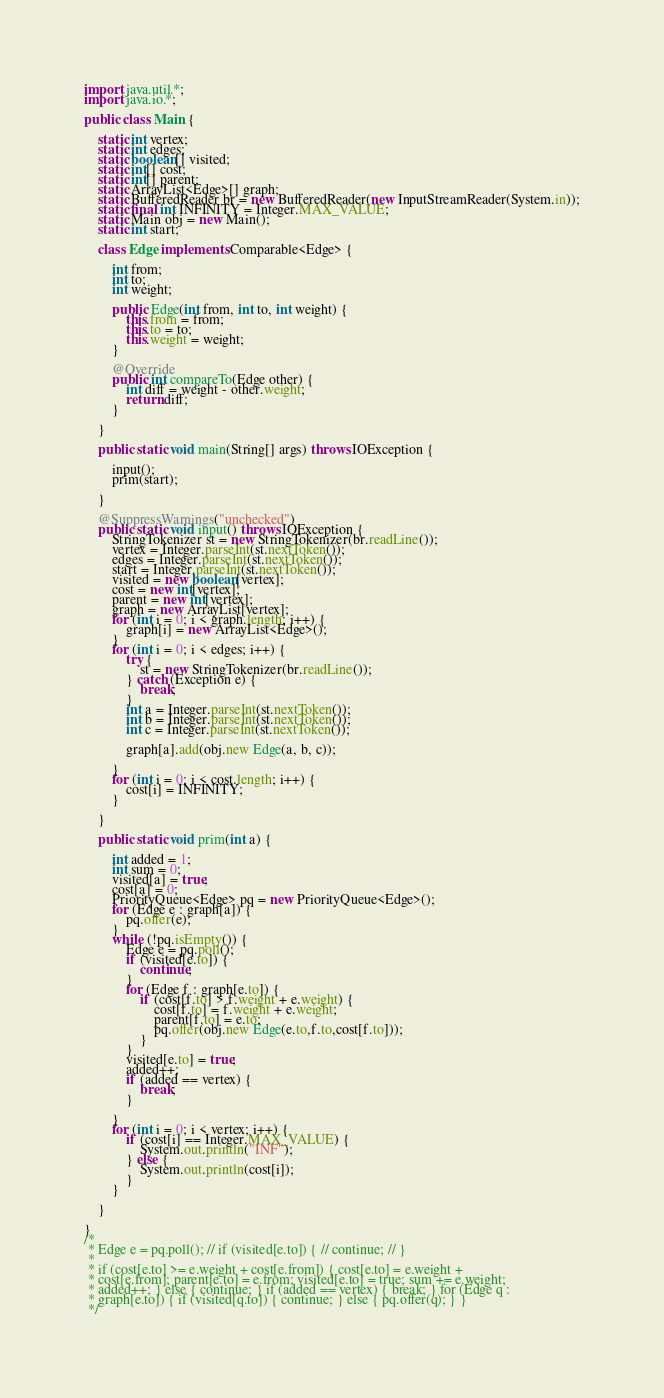Convert code to text. <code><loc_0><loc_0><loc_500><loc_500><_Java_>import java.util.*;
import java.io.*;

public class Main {

	static int vertex;
	static int edges;
	static boolean[] visited;
	static int[] cost;
	static int[] parent;
	static ArrayList<Edge>[] graph;
	static BufferedReader br = new BufferedReader(new InputStreamReader(System.in));
	static final int INFINITY = Integer.MAX_VALUE;
	static Main obj = new Main();
	static int start;

	class Edge implements Comparable<Edge> {

		int from;
		int to;
		int weight;

		public Edge(int from, int to, int weight) {
			this.from = from;
			this.to = to;
			this.weight = weight;
		}

		@Override
		public int compareTo(Edge other) {
			int diff = weight - other.weight;
			return diff;
		}

	}

	public static void main(String[] args) throws IOException {

		input();
		prim(start);

	}

	@SuppressWarnings("unchecked")
	public static void input() throws IOException {
		StringTokenizer st = new StringTokenizer(br.readLine());
		vertex = Integer.parseInt(st.nextToken());
		edges = Integer.parseInt(st.nextToken());
		start = Integer.parseInt(st.nextToken());
		visited = new boolean[vertex];
		cost = new int[vertex];
		parent = new int[vertex];
		graph = new ArrayList[vertex];
		for (int i = 0; i < graph.length; i++) {
			graph[i] = new ArrayList<Edge>();
		}
		for (int i = 0; i < edges; i++) {
			try {
				st = new StringTokenizer(br.readLine());
			} catch (Exception e) {
				break;
			}
			int a = Integer.parseInt(st.nextToken());
			int b = Integer.parseInt(st.nextToken());
			int c = Integer.parseInt(st.nextToken());

			graph[a].add(obj.new Edge(a, b, c));

		}
		for (int i = 0; i < cost.length; i++) {
			cost[i] = INFINITY;
		}

	}

	public static void prim(int a) {

		int added = 1;
		int sum = 0;
		visited[a] = true;
		cost[a] = 0;
		PriorityQueue<Edge> pq = new PriorityQueue<Edge>();
		for (Edge e : graph[a]) {
			pq.offer(e);
		}
		while (!pq.isEmpty()) {
			Edge e = pq.poll();
			if (visited[e.to]) {
				continue;
			}
			for (Edge f : graph[e.to]) {
				if (cost[f.to] > f.weight + e.weight) {
					cost[f.to] = f.weight + e.weight;
					parent[f.to] = e.to;
					pq.offer(obj.new Edge(e.to,f.to,cost[f.to]));
				}
			}
			visited[e.to] = true;
			added++;
			if (added == vertex) {
				break;
			}

		}
		for (int i = 0; i < vertex; i++) {
			if (cost[i] == Integer.MAX_VALUE) {
				System.out.println("INF");
			} else {
				System.out.println(cost[i]);
			}
		}

	}

}
/*
 * Edge e = pq.poll(); // if (visited[e.to]) { // continue; // }
 * 
 * if (cost[e.to] >= e.weight + cost[e.from]) { cost[e.to] = e.weight +
 * cost[e.from]; parent[e.to] = e.from; visited[e.to] = true; sum += e.weight;
 * added++; } else { continue; } if (added == vertex) { break; } for (Edge q :
 * graph[e.to]) { if (visited[q.to]) { continue; } else { pq.offer(q); } }
 */</code> 